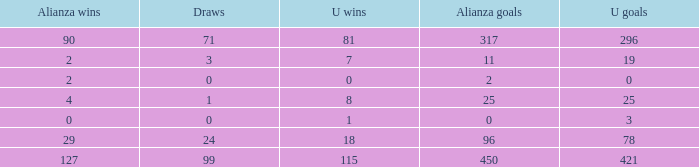What is the cumulative amount of u wins when alianza goals is "0" and u goals surpass 3? 0.0. 